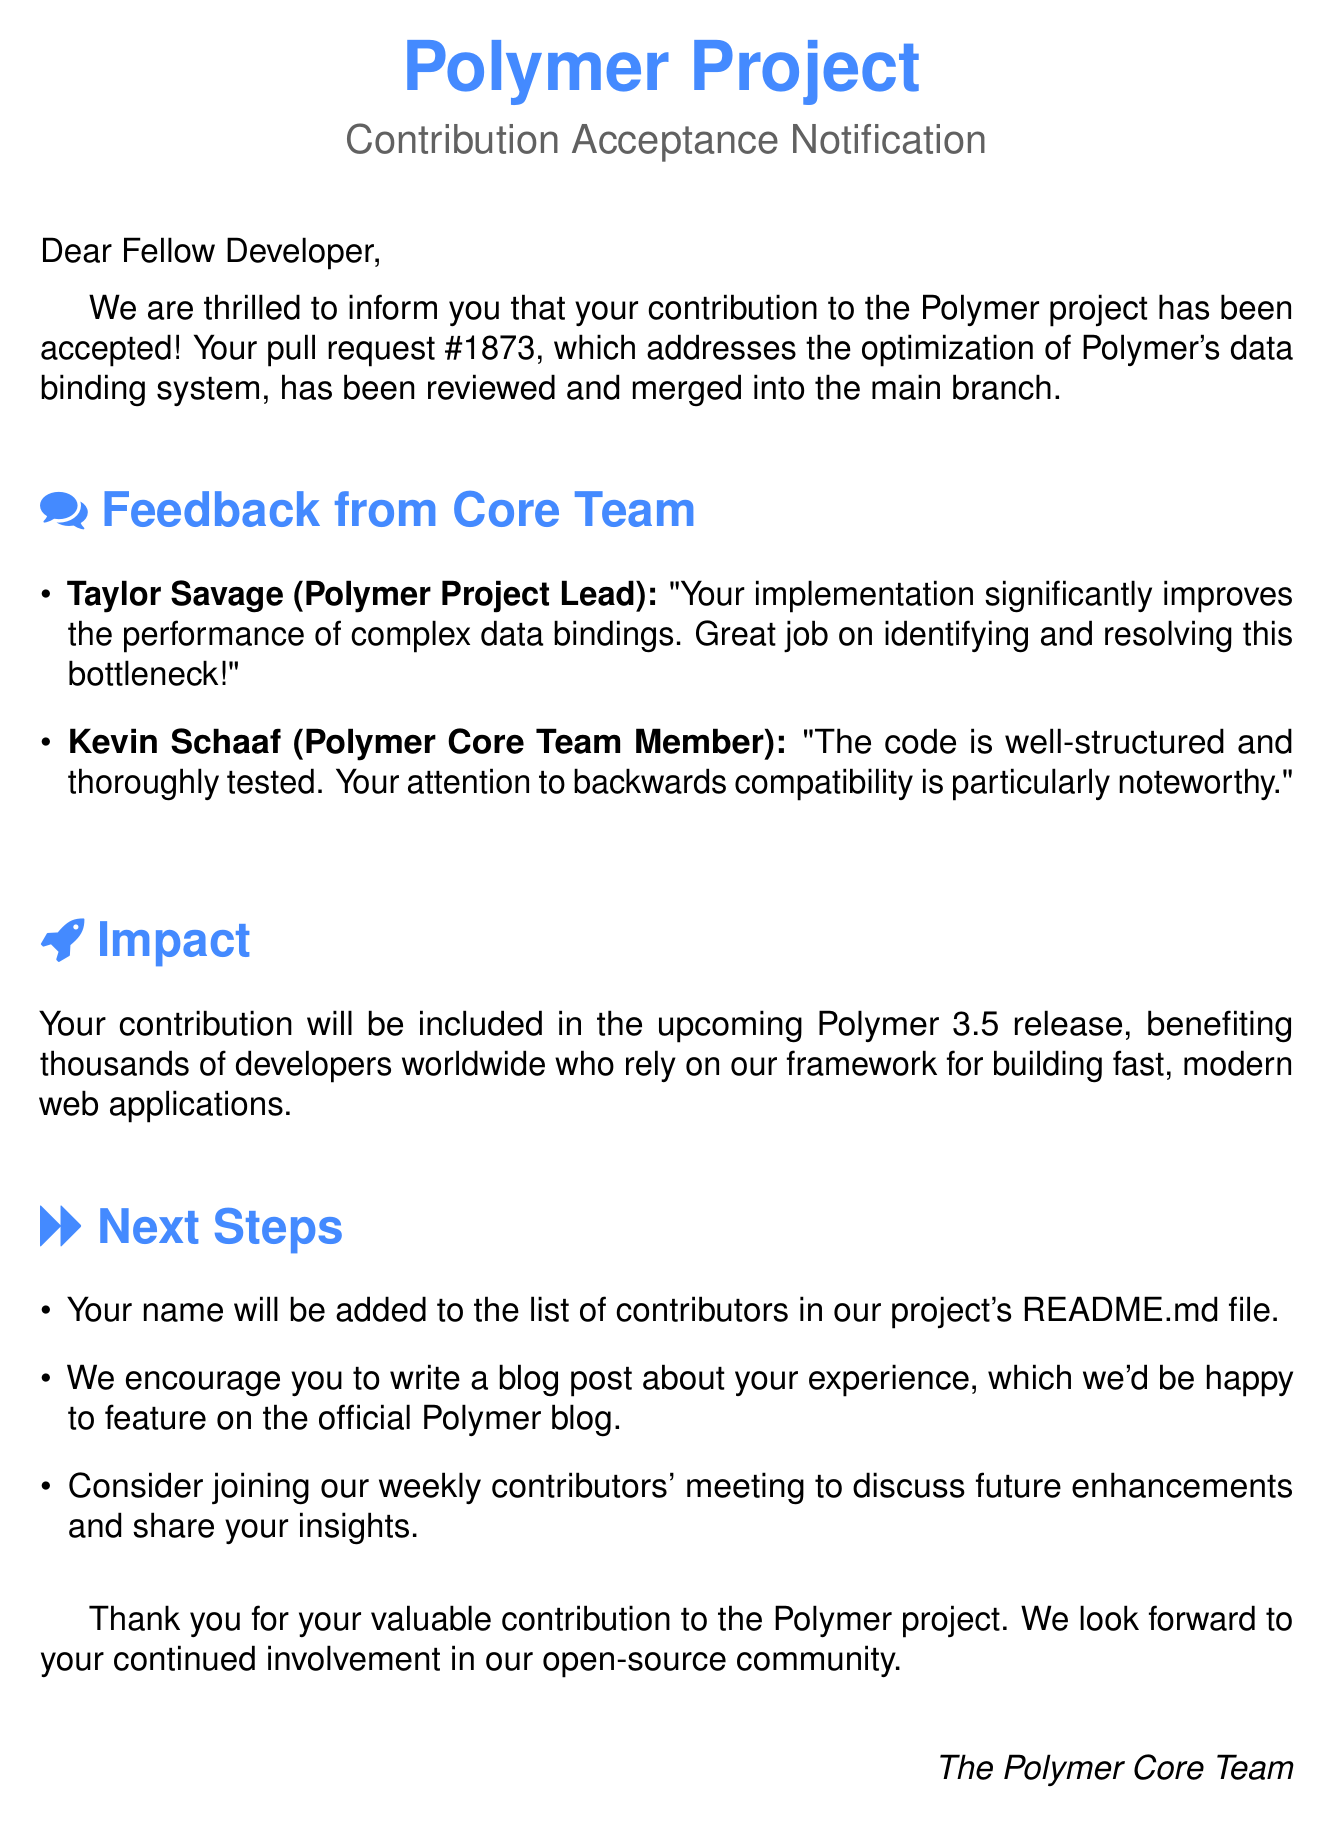What is the subject of the email? The subject is a key identification of the email content that informs the recipient about the acceptance of their contribution.
Answer: Acceptance of Your Contribution to Polymer Project What is the pull request number? The pull request number specifies the exact reference for the contribution made by the developer.
Answer: 1873 Who is the Polymer Project Lead? The Polymer Project Lead is the primary reviewer or authority who provides feedback on contributions in the project.
Answer: Taylor Savage What is the feedback provided by Kevin Schaaf? The feedback from the team member gives insights on the quality and structure of the code contributed to the project.
Answer: The code is well-structured and thoroughly tested. Your attention to backwards compatibility is particularly noteworthy In which release will the contribution be included? The release version informs the reader about when the accepted changes will be available to users.
Answer: 3.5 What does the document encourage the developer to write? This encourages additional engagement and sharing of personal experiences related to the contribution.
Answer: A blog post about your experience How will the developer's name be acknowledged? This detail specifies how the contribution will be recognized within the project documentation.
Answer: Added to the list of contributors in the project's README.md file What does the closing thank the developer for? The closing remark emphasizes appreciation for community involvement and contributions to the project.
Answer: Valuable contribution to the Polymer project 